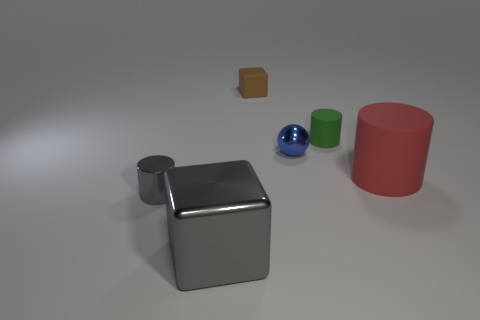What can you tell me about the spatial arrangement of these objects? These objects are arranged with ample space between them on a flat surface. The large metal cube is positioned prominently in the foreground, while the other objects are placed behind it, creating a sense of depth. Their placement might suggest an intentional design, perhaps for an educational purpose to demonstrate geometric shapes and contrasts. 